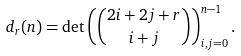<formula> <loc_0><loc_0><loc_500><loc_500>d _ { r } ( n ) = \det \left ( { 2 i + 2 j + r \choose i + j } \right ) _ { i , j = 0 } ^ { n - 1 } .</formula> 